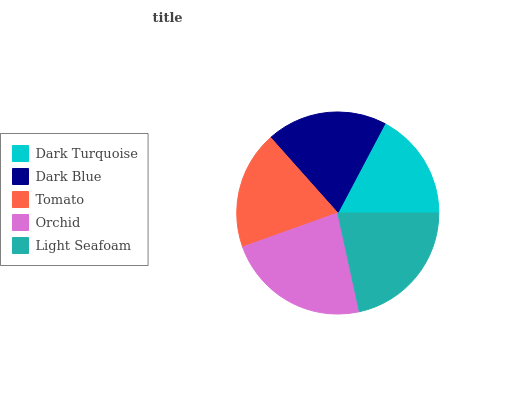Is Dark Turquoise the minimum?
Answer yes or no. Yes. Is Orchid the maximum?
Answer yes or no. Yes. Is Dark Blue the minimum?
Answer yes or no. No. Is Dark Blue the maximum?
Answer yes or no. No. Is Dark Blue greater than Dark Turquoise?
Answer yes or no. Yes. Is Dark Turquoise less than Dark Blue?
Answer yes or no. Yes. Is Dark Turquoise greater than Dark Blue?
Answer yes or no. No. Is Dark Blue less than Dark Turquoise?
Answer yes or no. No. Is Dark Blue the high median?
Answer yes or no. Yes. Is Dark Blue the low median?
Answer yes or no. Yes. Is Dark Turquoise the high median?
Answer yes or no. No. Is Dark Turquoise the low median?
Answer yes or no. No. 